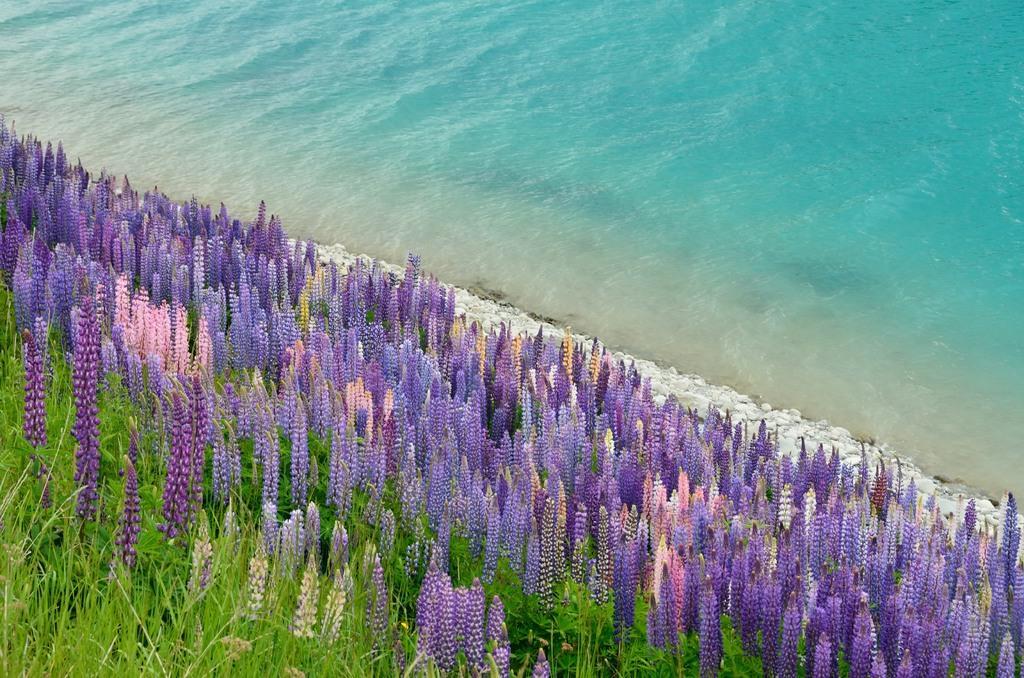Describe this image in one or two sentences. There are plants having flowers which are in different colors. In the background, there are stones on the ground and there is water. 